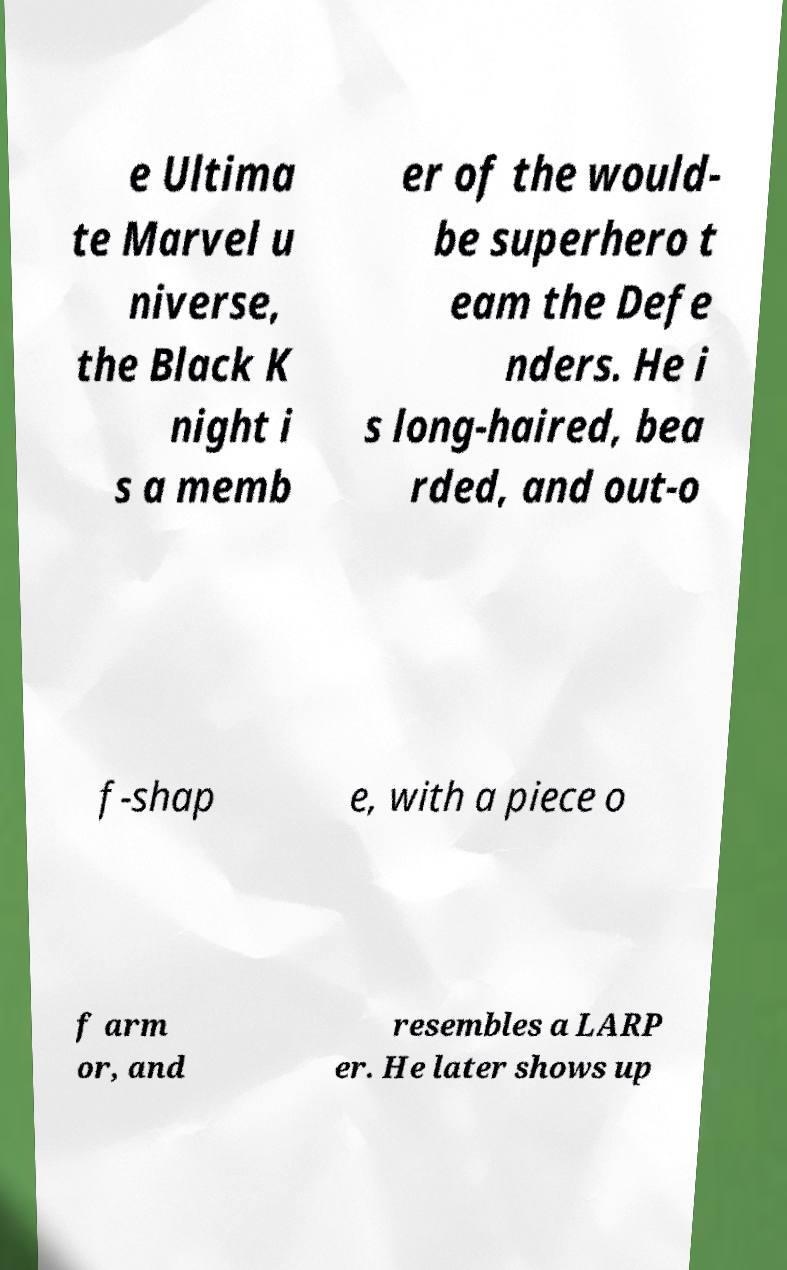Could you extract and type out the text from this image? e Ultima te Marvel u niverse, the Black K night i s a memb er of the would- be superhero t eam the Defe nders. He i s long-haired, bea rded, and out-o f-shap e, with a piece o f arm or, and resembles a LARP er. He later shows up 